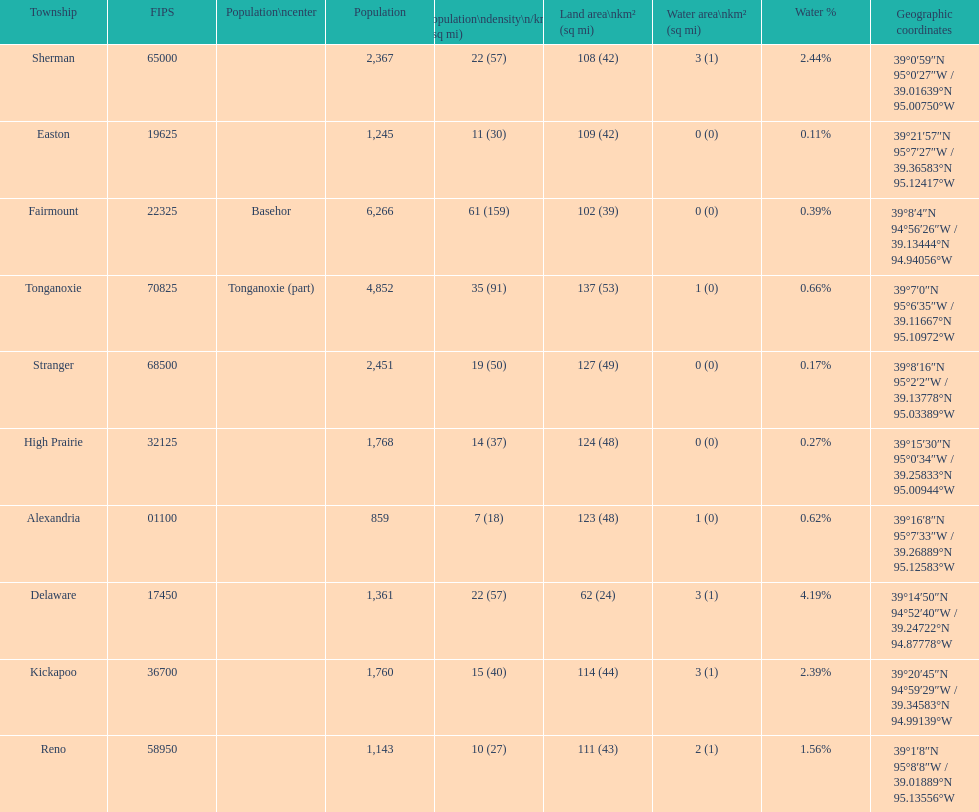What is the difference of population in easton and reno? 102. 